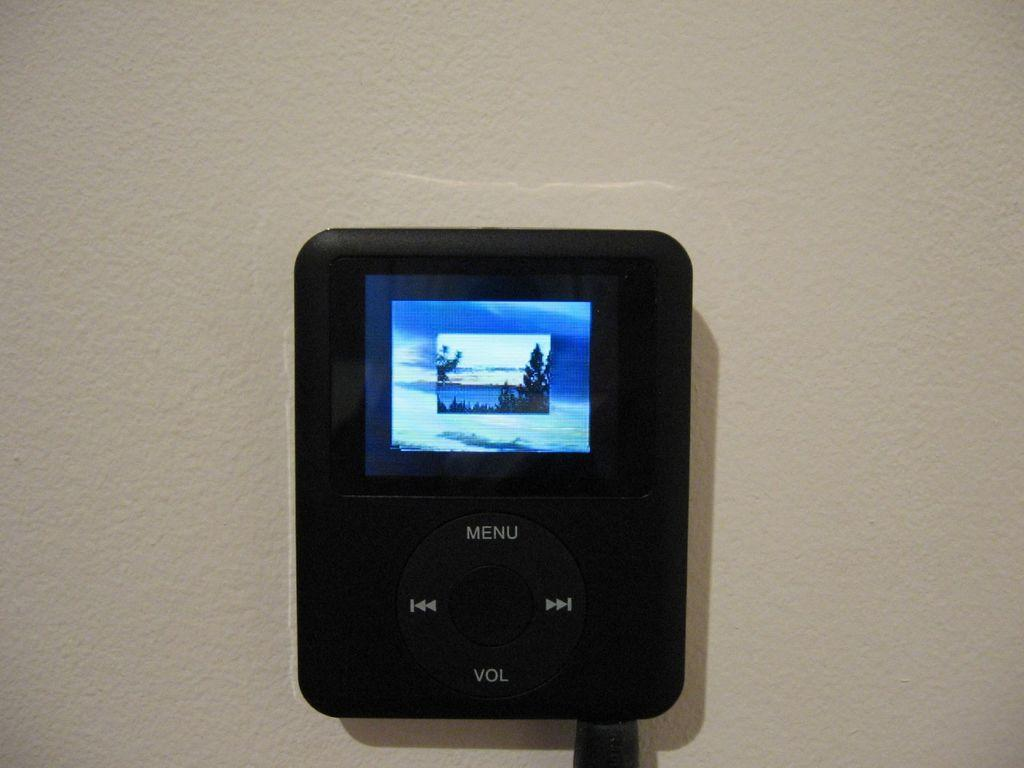What type of object is in the middle of the image? There is an electronic instrument in the middle of the image. Where is the electronic instrument located? The electronic instrument is attached to a wall. What type of crack can be seen on the brain in the image? There is no brain or crack present in the image; it features an electronic instrument attached to a wall. 